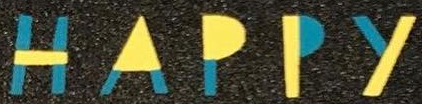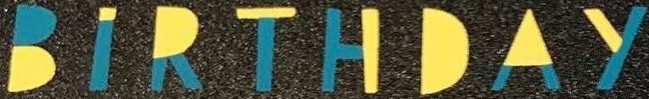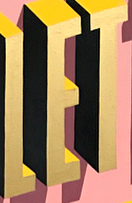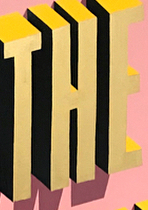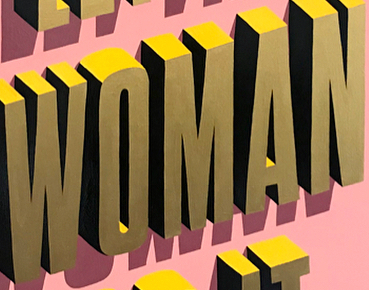Read the text from these images in sequence, separated by a semicolon. HAPPY; BIRTHDAY; LET; THE; WOMAN 